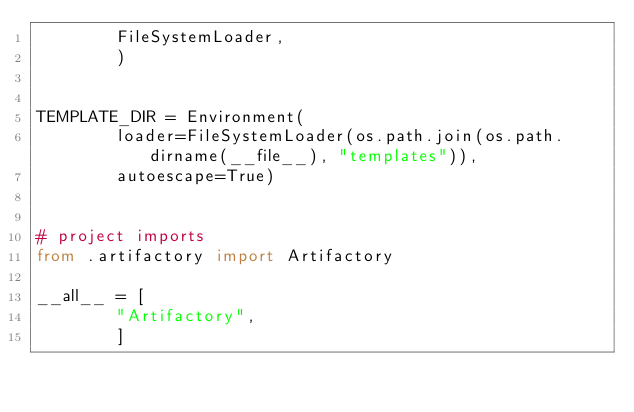<code> <loc_0><loc_0><loc_500><loc_500><_Python_>        FileSystemLoader,
        )


TEMPLATE_DIR = Environment(
        loader=FileSystemLoader(os.path.join(os.path.dirname(__file__), "templates")),
        autoescape=True)


# project imports
from .artifactory import Artifactory

__all__ = [
        "Artifactory",
        ]
</code> 